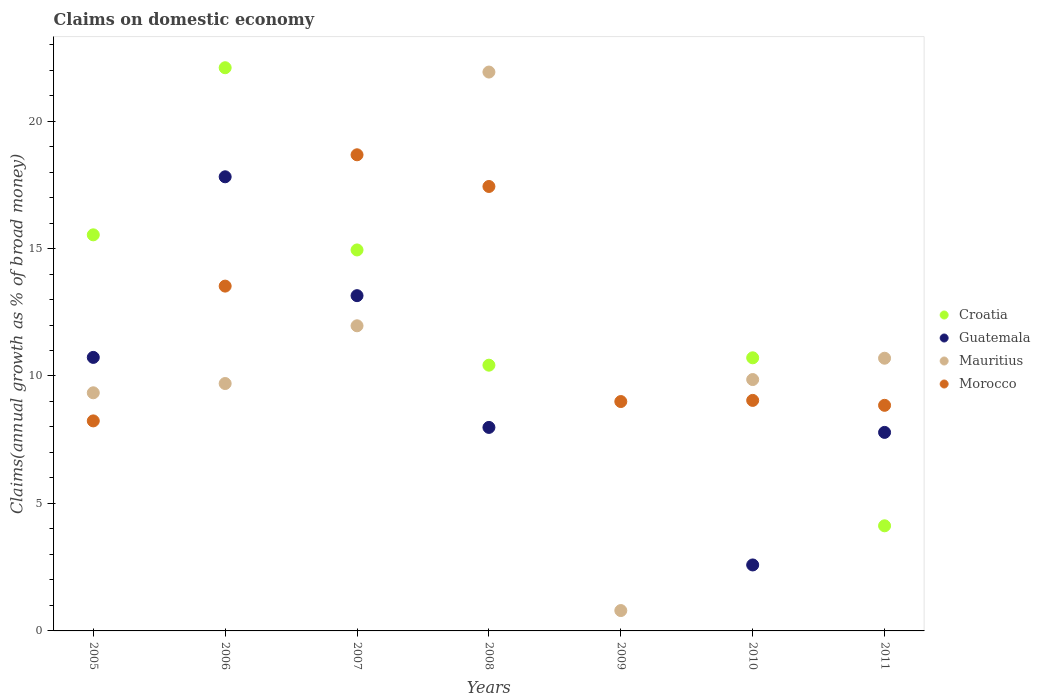Is the number of dotlines equal to the number of legend labels?
Offer a very short reply. No. What is the percentage of broad money claimed on domestic economy in Croatia in 2008?
Offer a very short reply. 10.42. Across all years, what is the maximum percentage of broad money claimed on domestic economy in Croatia?
Offer a very short reply. 22.09. Across all years, what is the minimum percentage of broad money claimed on domestic economy in Morocco?
Your answer should be compact. 8.24. In which year was the percentage of broad money claimed on domestic economy in Mauritius maximum?
Make the answer very short. 2008. What is the total percentage of broad money claimed on domestic economy in Morocco in the graph?
Your response must be concise. 84.77. What is the difference between the percentage of broad money claimed on domestic economy in Mauritius in 2008 and that in 2009?
Your answer should be very brief. 21.12. What is the difference between the percentage of broad money claimed on domestic economy in Mauritius in 2005 and the percentage of broad money claimed on domestic economy in Croatia in 2009?
Your answer should be compact. 9.34. What is the average percentage of broad money claimed on domestic economy in Mauritius per year?
Your answer should be compact. 10.61. In the year 2007, what is the difference between the percentage of broad money claimed on domestic economy in Croatia and percentage of broad money claimed on domestic economy in Mauritius?
Give a very brief answer. 2.97. What is the ratio of the percentage of broad money claimed on domestic economy in Morocco in 2010 to that in 2011?
Provide a succinct answer. 1.02. Is the percentage of broad money claimed on domestic economy in Mauritius in 2005 less than that in 2007?
Ensure brevity in your answer.  Yes. Is the difference between the percentage of broad money claimed on domestic economy in Croatia in 2005 and 2011 greater than the difference between the percentage of broad money claimed on domestic economy in Mauritius in 2005 and 2011?
Keep it short and to the point. Yes. What is the difference between the highest and the second highest percentage of broad money claimed on domestic economy in Mauritius?
Offer a terse response. 9.95. What is the difference between the highest and the lowest percentage of broad money claimed on domestic economy in Croatia?
Your answer should be very brief. 22.09. Does the percentage of broad money claimed on domestic economy in Guatemala monotonically increase over the years?
Your answer should be very brief. No. Is the percentage of broad money claimed on domestic economy in Morocco strictly greater than the percentage of broad money claimed on domestic economy in Mauritius over the years?
Make the answer very short. No. How many dotlines are there?
Offer a very short reply. 4. Are the values on the major ticks of Y-axis written in scientific E-notation?
Offer a very short reply. No. How are the legend labels stacked?
Ensure brevity in your answer.  Vertical. What is the title of the graph?
Offer a very short reply. Claims on domestic economy. What is the label or title of the Y-axis?
Keep it short and to the point. Claims(annual growth as % of broad money). What is the Claims(annual growth as % of broad money) in Croatia in 2005?
Make the answer very short. 15.54. What is the Claims(annual growth as % of broad money) in Guatemala in 2005?
Ensure brevity in your answer.  10.73. What is the Claims(annual growth as % of broad money) of Mauritius in 2005?
Ensure brevity in your answer.  9.34. What is the Claims(annual growth as % of broad money) in Morocco in 2005?
Provide a succinct answer. 8.24. What is the Claims(annual growth as % of broad money) of Croatia in 2006?
Your answer should be very brief. 22.09. What is the Claims(annual growth as % of broad money) in Guatemala in 2006?
Give a very brief answer. 17.81. What is the Claims(annual growth as % of broad money) in Mauritius in 2006?
Your answer should be compact. 9.7. What is the Claims(annual growth as % of broad money) of Morocco in 2006?
Provide a succinct answer. 13.53. What is the Claims(annual growth as % of broad money) of Croatia in 2007?
Your answer should be compact. 14.94. What is the Claims(annual growth as % of broad money) in Guatemala in 2007?
Offer a terse response. 13.15. What is the Claims(annual growth as % of broad money) in Mauritius in 2007?
Give a very brief answer. 11.97. What is the Claims(annual growth as % of broad money) of Morocco in 2007?
Give a very brief answer. 18.68. What is the Claims(annual growth as % of broad money) of Croatia in 2008?
Provide a short and direct response. 10.42. What is the Claims(annual growth as % of broad money) in Guatemala in 2008?
Give a very brief answer. 7.98. What is the Claims(annual growth as % of broad money) of Mauritius in 2008?
Keep it short and to the point. 21.92. What is the Claims(annual growth as % of broad money) in Morocco in 2008?
Offer a terse response. 17.43. What is the Claims(annual growth as % of broad money) in Mauritius in 2009?
Give a very brief answer. 0.8. What is the Claims(annual growth as % of broad money) of Morocco in 2009?
Your answer should be compact. 9. What is the Claims(annual growth as % of broad money) in Croatia in 2010?
Your response must be concise. 10.71. What is the Claims(annual growth as % of broad money) in Guatemala in 2010?
Your answer should be very brief. 2.59. What is the Claims(annual growth as % of broad money) of Mauritius in 2010?
Give a very brief answer. 9.86. What is the Claims(annual growth as % of broad money) of Morocco in 2010?
Give a very brief answer. 9.04. What is the Claims(annual growth as % of broad money) of Croatia in 2011?
Make the answer very short. 4.12. What is the Claims(annual growth as % of broad money) of Guatemala in 2011?
Provide a succinct answer. 7.79. What is the Claims(annual growth as % of broad money) of Mauritius in 2011?
Offer a very short reply. 10.7. What is the Claims(annual growth as % of broad money) of Morocco in 2011?
Provide a succinct answer. 8.85. Across all years, what is the maximum Claims(annual growth as % of broad money) of Croatia?
Provide a succinct answer. 22.09. Across all years, what is the maximum Claims(annual growth as % of broad money) of Guatemala?
Make the answer very short. 17.81. Across all years, what is the maximum Claims(annual growth as % of broad money) of Mauritius?
Give a very brief answer. 21.92. Across all years, what is the maximum Claims(annual growth as % of broad money) in Morocco?
Ensure brevity in your answer.  18.68. Across all years, what is the minimum Claims(annual growth as % of broad money) of Croatia?
Offer a very short reply. 0. Across all years, what is the minimum Claims(annual growth as % of broad money) of Mauritius?
Your answer should be very brief. 0.8. Across all years, what is the minimum Claims(annual growth as % of broad money) of Morocco?
Your response must be concise. 8.24. What is the total Claims(annual growth as % of broad money) of Croatia in the graph?
Give a very brief answer. 77.84. What is the total Claims(annual growth as % of broad money) in Guatemala in the graph?
Keep it short and to the point. 60.05. What is the total Claims(annual growth as % of broad money) of Mauritius in the graph?
Your answer should be compact. 74.29. What is the total Claims(annual growth as % of broad money) of Morocco in the graph?
Offer a terse response. 84.77. What is the difference between the Claims(annual growth as % of broad money) in Croatia in 2005 and that in 2006?
Your response must be concise. -6.55. What is the difference between the Claims(annual growth as % of broad money) in Guatemala in 2005 and that in 2006?
Make the answer very short. -7.08. What is the difference between the Claims(annual growth as % of broad money) in Mauritius in 2005 and that in 2006?
Keep it short and to the point. -0.36. What is the difference between the Claims(annual growth as % of broad money) in Morocco in 2005 and that in 2006?
Provide a succinct answer. -5.29. What is the difference between the Claims(annual growth as % of broad money) in Croatia in 2005 and that in 2007?
Keep it short and to the point. 0.59. What is the difference between the Claims(annual growth as % of broad money) in Guatemala in 2005 and that in 2007?
Offer a terse response. -2.42. What is the difference between the Claims(annual growth as % of broad money) in Mauritius in 2005 and that in 2007?
Keep it short and to the point. -2.63. What is the difference between the Claims(annual growth as % of broad money) of Morocco in 2005 and that in 2007?
Your answer should be very brief. -10.44. What is the difference between the Claims(annual growth as % of broad money) of Croatia in 2005 and that in 2008?
Your response must be concise. 5.11. What is the difference between the Claims(annual growth as % of broad money) in Guatemala in 2005 and that in 2008?
Offer a very short reply. 2.75. What is the difference between the Claims(annual growth as % of broad money) in Mauritius in 2005 and that in 2008?
Offer a very short reply. -12.58. What is the difference between the Claims(annual growth as % of broad money) of Morocco in 2005 and that in 2008?
Provide a short and direct response. -9.2. What is the difference between the Claims(annual growth as % of broad money) in Mauritius in 2005 and that in 2009?
Your response must be concise. 8.54. What is the difference between the Claims(annual growth as % of broad money) in Morocco in 2005 and that in 2009?
Provide a short and direct response. -0.76. What is the difference between the Claims(annual growth as % of broad money) of Croatia in 2005 and that in 2010?
Ensure brevity in your answer.  4.82. What is the difference between the Claims(annual growth as % of broad money) in Guatemala in 2005 and that in 2010?
Your response must be concise. 8.14. What is the difference between the Claims(annual growth as % of broad money) of Mauritius in 2005 and that in 2010?
Ensure brevity in your answer.  -0.52. What is the difference between the Claims(annual growth as % of broad money) in Morocco in 2005 and that in 2010?
Offer a terse response. -0.8. What is the difference between the Claims(annual growth as % of broad money) of Croatia in 2005 and that in 2011?
Your response must be concise. 11.41. What is the difference between the Claims(annual growth as % of broad money) in Guatemala in 2005 and that in 2011?
Offer a very short reply. 2.94. What is the difference between the Claims(annual growth as % of broad money) in Mauritius in 2005 and that in 2011?
Offer a very short reply. -1.36. What is the difference between the Claims(annual growth as % of broad money) in Morocco in 2005 and that in 2011?
Your response must be concise. -0.61. What is the difference between the Claims(annual growth as % of broad money) in Croatia in 2006 and that in 2007?
Your answer should be very brief. 7.15. What is the difference between the Claims(annual growth as % of broad money) of Guatemala in 2006 and that in 2007?
Make the answer very short. 4.66. What is the difference between the Claims(annual growth as % of broad money) in Mauritius in 2006 and that in 2007?
Provide a short and direct response. -2.27. What is the difference between the Claims(annual growth as % of broad money) of Morocco in 2006 and that in 2007?
Offer a very short reply. -5.15. What is the difference between the Claims(annual growth as % of broad money) of Croatia in 2006 and that in 2008?
Your answer should be very brief. 11.67. What is the difference between the Claims(annual growth as % of broad money) of Guatemala in 2006 and that in 2008?
Provide a succinct answer. 9.83. What is the difference between the Claims(annual growth as % of broad money) of Mauritius in 2006 and that in 2008?
Your response must be concise. -12.22. What is the difference between the Claims(annual growth as % of broad money) of Morocco in 2006 and that in 2008?
Your response must be concise. -3.91. What is the difference between the Claims(annual growth as % of broad money) of Mauritius in 2006 and that in 2009?
Give a very brief answer. 8.91. What is the difference between the Claims(annual growth as % of broad money) in Morocco in 2006 and that in 2009?
Your response must be concise. 4.53. What is the difference between the Claims(annual growth as % of broad money) in Croatia in 2006 and that in 2010?
Make the answer very short. 11.38. What is the difference between the Claims(annual growth as % of broad money) of Guatemala in 2006 and that in 2010?
Your response must be concise. 15.23. What is the difference between the Claims(annual growth as % of broad money) of Mauritius in 2006 and that in 2010?
Ensure brevity in your answer.  -0.16. What is the difference between the Claims(annual growth as % of broad money) of Morocco in 2006 and that in 2010?
Keep it short and to the point. 4.48. What is the difference between the Claims(annual growth as % of broad money) in Croatia in 2006 and that in 2011?
Your response must be concise. 17.97. What is the difference between the Claims(annual growth as % of broad money) of Guatemala in 2006 and that in 2011?
Ensure brevity in your answer.  10.03. What is the difference between the Claims(annual growth as % of broad money) of Mauritius in 2006 and that in 2011?
Ensure brevity in your answer.  -0.99. What is the difference between the Claims(annual growth as % of broad money) of Morocco in 2006 and that in 2011?
Offer a very short reply. 4.68. What is the difference between the Claims(annual growth as % of broad money) in Croatia in 2007 and that in 2008?
Make the answer very short. 4.52. What is the difference between the Claims(annual growth as % of broad money) of Guatemala in 2007 and that in 2008?
Ensure brevity in your answer.  5.17. What is the difference between the Claims(annual growth as % of broad money) in Mauritius in 2007 and that in 2008?
Provide a short and direct response. -9.95. What is the difference between the Claims(annual growth as % of broad money) of Morocco in 2007 and that in 2008?
Offer a terse response. 1.24. What is the difference between the Claims(annual growth as % of broad money) of Mauritius in 2007 and that in 2009?
Keep it short and to the point. 11.17. What is the difference between the Claims(annual growth as % of broad money) in Morocco in 2007 and that in 2009?
Make the answer very short. 9.68. What is the difference between the Claims(annual growth as % of broad money) of Croatia in 2007 and that in 2010?
Your answer should be very brief. 4.23. What is the difference between the Claims(annual growth as % of broad money) of Guatemala in 2007 and that in 2010?
Offer a terse response. 10.56. What is the difference between the Claims(annual growth as % of broad money) of Mauritius in 2007 and that in 2010?
Your answer should be very brief. 2.11. What is the difference between the Claims(annual growth as % of broad money) in Morocco in 2007 and that in 2010?
Offer a very short reply. 9.63. What is the difference between the Claims(annual growth as % of broad money) in Croatia in 2007 and that in 2011?
Offer a very short reply. 10.82. What is the difference between the Claims(annual growth as % of broad money) in Guatemala in 2007 and that in 2011?
Give a very brief answer. 5.36. What is the difference between the Claims(annual growth as % of broad money) of Mauritius in 2007 and that in 2011?
Your response must be concise. 1.27. What is the difference between the Claims(annual growth as % of broad money) of Morocco in 2007 and that in 2011?
Ensure brevity in your answer.  9.83. What is the difference between the Claims(annual growth as % of broad money) in Mauritius in 2008 and that in 2009?
Your response must be concise. 21.12. What is the difference between the Claims(annual growth as % of broad money) in Morocco in 2008 and that in 2009?
Ensure brevity in your answer.  8.44. What is the difference between the Claims(annual growth as % of broad money) of Croatia in 2008 and that in 2010?
Ensure brevity in your answer.  -0.29. What is the difference between the Claims(annual growth as % of broad money) of Guatemala in 2008 and that in 2010?
Your answer should be compact. 5.39. What is the difference between the Claims(annual growth as % of broad money) of Mauritius in 2008 and that in 2010?
Give a very brief answer. 12.06. What is the difference between the Claims(annual growth as % of broad money) in Morocco in 2008 and that in 2010?
Keep it short and to the point. 8.39. What is the difference between the Claims(annual growth as % of broad money) in Croatia in 2008 and that in 2011?
Make the answer very short. 6.3. What is the difference between the Claims(annual growth as % of broad money) of Guatemala in 2008 and that in 2011?
Your answer should be very brief. 0.2. What is the difference between the Claims(annual growth as % of broad money) of Mauritius in 2008 and that in 2011?
Your response must be concise. 11.23. What is the difference between the Claims(annual growth as % of broad money) in Morocco in 2008 and that in 2011?
Provide a succinct answer. 8.58. What is the difference between the Claims(annual growth as % of broad money) of Mauritius in 2009 and that in 2010?
Provide a succinct answer. -9.06. What is the difference between the Claims(annual growth as % of broad money) of Morocco in 2009 and that in 2010?
Your response must be concise. -0.04. What is the difference between the Claims(annual growth as % of broad money) of Mauritius in 2009 and that in 2011?
Provide a succinct answer. -9.9. What is the difference between the Claims(annual growth as % of broad money) of Morocco in 2009 and that in 2011?
Your answer should be very brief. 0.15. What is the difference between the Claims(annual growth as % of broad money) of Croatia in 2010 and that in 2011?
Provide a short and direct response. 6.59. What is the difference between the Claims(annual growth as % of broad money) of Guatemala in 2010 and that in 2011?
Provide a succinct answer. -5.2. What is the difference between the Claims(annual growth as % of broad money) of Mauritius in 2010 and that in 2011?
Keep it short and to the point. -0.84. What is the difference between the Claims(annual growth as % of broad money) of Morocco in 2010 and that in 2011?
Offer a terse response. 0.19. What is the difference between the Claims(annual growth as % of broad money) in Croatia in 2005 and the Claims(annual growth as % of broad money) in Guatemala in 2006?
Your answer should be very brief. -2.28. What is the difference between the Claims(annual growth as % of broad money) of Croatia in 2005 and the Claims(annual growth as % of broad money) of Mauritius in 2006?
Your answer should be very brief. 5.83. What is the difference between the Claims(annual growth as % of broad money) in Croatia in 2005 and the Claims(annual growth as % of broad money) in Morocco in 2006?
Ensure brevity in your answer.  2.01. What is the difference between the Claims(annual growth as % of broad money) in Guatemala in 2005 and the Claims(annual growth as % of broad money) in Mauritius in 2006?
Provide a short and direct response. 1.02. What is the difference between the Claims(annual growth as % of broad money) of Guatemala in 2005 and the Claims(annual growth as % of broad money) of Morocco in 2006?
Provide a short and direct response. -2.8. What is the difference between the Claims(annual growth as % of broad money) in Mauritius in 2005 and the Claims(annual growth as % of broad money) in Morocco in 2006?
Give a very brief answer. -4.18. What is the difference between the Claims(annual growth as % of broad money) of Croatia in 2005 and the Claims(annual growth as % of broad money) of Guatemala in 2007?
Give a very brief answer. 2.39. What is the difference between the Claims(annual growth as % of broad money) of Croatia in 2005 and the Claims(annual growth as % of broad money) of Mauritius in 2007?
Provide a succinct answer. 3.57. What is the difference between the Claims(annual growth as % of broad money) in Croatia in 2005 and the Claims(annual growth as % of broad money) in Morocco in 2007?
Your answer should be compact. -3.14. What is the difference between the Claims(annual growth as % of broad money) of Guatemala in 2005 and the Claims(annual growth as % of broad money) of Mauritius in 2007?
Provide a short and direct response. -1.24. What is the difference between the Claims(annual growth as % of broad money) of Guatemala in 2005 and the Claims(annual growth as % of broad money) of Morocco in 2007?
Provide a short and direct response. -7.95. What is the difference between the Claims(annual growth as % of broad money) in Mauritius in 2005 and the Claims(annual growth as % of broad money) in Morocco in 2007?
Ensure brevity in your answer.  -9.34. What is the difference between the Claims(annual growth as % of broad money) of Croatia in 2005 and the Claims(annual growth as % of broad money) of Guatemala in 2008?
Provide a succinct answer. 7.55. What is the difference between the Claims(annual growth as % of broad money) in Croatia in 2005 and the Claims(annual growth as % of broad money) in Mauritius in 2008?
Your response must be concise. -6.39. What is the difference between the Claims(annual growth as % of broad money) of Croatia in 2005 and the Claims(annual growth as % of broad money) of Morocco in 2008?
Offer a terse response. -1.9. What is the difference between the Claims(annual growth as % of broad money) of Guatemala in 2005 and the Claims(annual growth as % of broad money) of Mauritius in 2008?
Make the answer very short. -11.19. What is the difference between the Claims(annual growth as % of broad money) of Guatemala in 2005 and the Claims(annual growth as % of broad money) of Morocco in 2008?
Provide a short and direct response. -6.7. What is the difference between the Claims(annual growth as % of broad money) in Mauritius in 2005 and the Claims(annual growth as % of broad money) in Morocco in 2008?
Provide a succinct answer. -8.09. What is the difference between the Claims(annual growth as % of broad money) of Croatia in 2005 and the Claims(annual growth as % of broad money) of Mauritius in 2009?
Your answer should be very brief. 14.74. What is the difference between the Claims(annual growth as % of broad money) in Croatia in 2005 and the Claims(annual growth as % of broad money) in Morocco in 2009?
Keep it short and to the point. 6.54. What is the difference between the Claims(annual growth as % of broad money) in Guatemala in 2005 and the Claims(annual growth as % of broad money) in Mauritius in 2009?
Offer a very short reply. 9.93. What is the difference between the Claims(annual growth as % of broad money) of Guatemala in 2005 and the Claims(annual growth as % of broad money) of Morocco in 2009?
Make the answer very short. 1.73. What is the difference between the Claims(annual growth as % of broad money) of Mauritius in 2005 and the Claims(annual growth as % of broad money) of Morocco in 2009?
Provide a short and direct response. 0.34. What is the difference between the Claims(annual growth as % of broad money) in Croatia in 2005 and the Claims(annual growth as % of broad money) in Guatemala in 2010?
Give a very brief answer. 12.95. What is the difference between the Claims(annual growth as % of broad money) of Croatia in 2005 and the Claims(annual growth as % of broad money) of Mauritius in 2010?
Your response must be concise. 5.68. What is the difference between the Claims(annual growth as % of broad money) of Croatia in 2005 and the Claims(annual growth as % of broad money) of Morocco in 2010?
Offer a terse response. 6.49. What is the difference between the Claims(annual growth as % of broad money) of Guatemala in 2005 and the Claims(annual growth as % of broad money) of Mauritius in 2010?
Provide a succinct answer. 0.87. What is the difference between the Claims(annual growth as % of broad money) in Guatemala in 2005 and the Claims(annual growth as % of broad money) in Morocco in 2010?
Keep it short and to the point. 1.69. What is the difference between the Claims(annual growth as % of broad money) in Mauritius in 2005 and the Claims(annual growth as % of broad money) in Morocco in 2010?
Give a very brief answer. 0.3. What is the difference between the Claims(annual growth as % of broad money) of Croatia in 2005 and the Claims(annual growth as % of broad money) of Guatemala in 2011?
Your answer should be compact. 7.75. What is the difference between the Claims(annual growth as % of broad money) in Croatia in 2005 and the Claims(annual growth as % of broad money) in Mauritius in 2011?
Provide a succinct answer. 4.84. What is the difference between the Claims(annual growth as % of broad money) of Croatia in 2005 and the Claims(annual growth as % of broad money) of Morocco in 2011?
Your answer should be compact. 6.69. What is the difference between the Claims(annual growth as % of broad money) in Guatemala in 2005 and the Claims(annual growth as % of broad money) in Mauritius in 2011?
Offer a very short reply. 0.03. What is the difference between the Claims(annual growth as % of broad money) of Guatemala in 2005 and the Claims(annual growth as % of broad money) of Morocco in 2011?
Offer a very short reply. 1.88. What is the difference between the Claims(annual growth as % of broad money) of Mauritius in 2005 and the Claims(annual growth as % of broad money) of Morocco in 2011?
Provide a short and direct response. 0.49. What is the difference between the Claims(annual growth as % of broad money) of Croatia in 2006 and the Claims(annual growth as % of broad money) of Guatemala in 2007?
Offer a very short reply. 8.94. What is the difference between the Claims(annual growth as % of broad money) in Croatia in 2006 and the Claims(annual growth as % of broad money) in Mauritius in 2007?
Ensure brevity in your answer.  10.12. What is the difference between the Claims(annual growth as % of broad money) of Croatia in 2006 and the Claims(annual growth as % of broad money) of Morocco in 2007?
Ensure brevity in your answer.  3.42. What is the difference between the Claims(annual growth as % of broad money) in Guatemala in 2006 and the Claims(annual growth as % of broad money) in Mauritius in 2007?
Keep it short and to the point. 5.84. What is the difference between the Claims(annual growth as % of broad money) in Guatemala in 2006 and the Claims(annual growth as % of broad money) in Morocco in 2007?
Keep it short and to the point. -0.86. What is the difference between the Claims(annual growth as % of broad money) in Mauritius in 2006 and the Claims(annual growth as % of broad money) in Morocco in 2007?
Provide a succinct answer. -8.97. What is the difference between the Claims(annual growth as % of broad money) of Croatia in 2006 and the Claims(annual growth as % of broad money) of Guatemala in 2008?
Make the answer very short. 14.11. What is the difference between the Claims(annual growth as % of broad money) of Croatia in 2006 and the Claims(annual growth as % of broad money) of Mauritius in 2008?
Provide a short and direct response. 0.17. What is the difference between the Claims(annual growth as % of broad money) in Croatia in 2006 and the Claims(annual growth as % of broad money) in Morocco in 2008?
Provide a succinct answer. 4.66. What is the difference between the Claims(annual growth as % of broad money) in Guatemala in 2006 and the Claims(annual growth as % of broad money) in Mauritius in 2008?
Offer a very short reply. -4.11. What is the difference between the Claims(annual growth as % of broad money) in Guatemala in 2006 and the Claims(annual growth as % of broad money) in Morocco in 2008?
Your response must be concise. 0.38. What is the difference between the Claims(annual growth as % of broad money) in Mauritius in 2006 and the Claims(annual growth as % of broad money) in Morocco in 2008?
Make the answer very short. -7.73. What is the difference between the Claims(annual growth as % of broad money) of Croatia in 2006 and the Claims(annual growth as % of broad money) of Mauritius in 2009?
Your answer should be very brief. 21.29. What is the difference between the Claims(annual growth as % of broad money) of Croatia in 2006 and the Claims(annual growth as % of broad money) of Morocco in 2009?
Provide a succinct answer. 13.09. What is the difference between the Claims(annual growth as % of broad money) of Guatemala in 2006 and the Claims(annual growth as % of broad money) of Mauritius in 2009?
Give a very brief answer. 17.02. What is the difference between the Claims(annual growth as % of broad money) in Guatemala in 2006 and the Claims(annual growth as % of broad money) in Morocco in 2009?
Give a very brief answer. 8.82. What is the difference between the Claims(annual growth as % of broad money) in Mauritius in 2006 and the Claims(annual growth as % of broad money) in Morocco in 2009?
Provide a succinct answer. 0.71. What is the difference between the Claims(annual growth as % of broad money) in Croatia in 2006 and the Claims(annual growth as % of broad money) in Guatemala in 2010?
Offer a very short reply. 19.5. What is the difference between the Claims(annual growth as % of broad money) in Croatia in 2006 and the Claims(annual growth as % of broad money) in Mauritius in 2010?
Provide a succinct answer. 12.23. What is the difference between the Claims(annual growth as % of broad money) of Croatia in 2006 and the Claims(annual growth as % of broad money) of Morocco in 2010?
Ensure brevity in your answer.  13.05. What is the difference between the Claims(annual growth as % of broad money) of Guatemala in 2006 and the Claims(annual growth as % of broad money) of Mauritius in 2010?
Provide a short and direct response. 7.95. What is the difference between the Claims(annual growth as % of broad money) of Guatemala in 2006 and the Claims(annual growth as % of broad money) of Morocco in 2010?
Your response must be concise. 8.77. What is the difference between the Claims(annual growth as % of broad money) in Mauritius in 2006 and the Claims(annual growth as % of broad money) in Morocco in 2010?
Give a very brief answer. 0.66. What is the difference between the Claims(annual growth as % of broad money) of Croatia in 2006 and the Claims(annual growth as % of broad money) of Guatemala in 2011?
Offer a terse response. 14.3. What is the difference between the Claims(annual growth as % of broad money) in Croatia in 2006 and the Claims(annual growth as % of broad money) in Mauritius in 2011?
Provide a succinct answer. 11.39. What is the difference between the Claims(annual growth as % of broad money) in Croatia in 2006 and the Claims(annual growth as % of broad money) in Morocco in 2011?
Give a very brief answer. 13.24. What is the difference between the Claims(annual growth as % of broad money) in Guatemala in 2006 and the Claims(annual growth as % of broad money) in Mauritius in 2011?
Offer a terse response. 7.12. What is the difference between the Claims(annual growth as % of broad money) of Guatemala in 2006 and the Claims(annual growth as % of broad money) of Morocco in 2011?
Ensure brevity in your answer.  8.96. What is the difference between the Claims(annual growth as % of broad money) in Mauritius in 2006 and the Claims(annual growth as % of broad money) in Morocco in 2011?
Provide a short and direct response. 0.85. What is the difference between the Claims(annual growth as % of broad money) of Croatia in 2007 and the Claims(annual growth as % of broad money) of Guatemala in 2008?
Offer a very short reply. 6.96. What is the difference between the Claims(annual growth as % of broad money) of Croatia in 2007 and the Claims(annual growth as % of broad money) of Mauritius in 2008?
Provide a short and direct response. -6.98. What is the difference between the Claims(annual growth as % of broad money) of Croatia in 2007 and the Claims(annual growth as % of broad money) of Morocco in 2008?
Provide a succinct answer. -2.49. What is the difference between the Claims(annual growth as % of broad money) in Guatemala in 2007 and the Claims(annual growth as % of broad money) in Mauritius in 2008?
Give a very brief answer. -8.77. What is the difference between the Claims(annual growth as % of broad money) in Guatemala in 2007 and the Claims(annual growth as % of broad money) in Morocco in 2008?
Provide a succinct answer. -4.28. What is the difference between the Claims(annual growth as % of broad money) of Mauritius in 2007 and the Claims(annual growth as % of broad money) of Morocco in 2008?
Provide a short and direct response. -5.46. What is the difference between the Claims(annual growth as % of broad money) in Croatia in 2007 and the Claims(annual growth as % of broad money) in Mauritius in 2009?
Give a very brief answer. 14.15. What is the difference between the Claims(annual growth as % of broad money) of Croatia in 2007 and the Claims(annual growth as % of broad money) of Morocco in 2009?
Give a very brief answer. 5.95. What is the difference between the Claims(annual growth as % of broad money) in Guatemala in 2007 and the Claims(annual growth as % of broad money) in Mauritius in 2009?
Offer a terse response. 12.35. What is the difference between the Claims(annual growth as % of broad money) of Guatemala in 2007 and the Claims(annual growth as % of broad money) of Morocco in 2009?
Your answer should be very brief. 4.15. What is the difference between the Claims(annual growth as % of broad money) in Mauritius in 2007 and the Claims(annual growth as % of broad money) in Morocco in 2009?
Make the answer very short. 2.97. What is the difference between the Claims(annual growth as % of broad money) of Croatia in 2007 and the Claims(annual growth as % of broad money) of Guatemala in 2010?
Provide a succinct answer. 12.36. What is the difference between the Claims(annual growth as % of broad money) in Croatia in 2007 and the Claims(annual growth as % of broad money) in Mauritius in 2010?
Make the answer very short. 5.08. What is the difference between the Claims(annual growth as % of broad money) in Croatia in 2007 and the Claims(annual growth as % of broad money) in Morocco in 2010?
Provide a short and direct response. 5.9. What is the difference between the Claims(annual growth as % of broad money) in Guatemala in 2007 and the Claims(annual growth as % of broad money) in Mauritius in 2010?
Provide a short and direct response. 3.29. What is the difference between the Claims(annual growth as % of broad money) in Guatemala in 2007 and the Claims(annual growth as % of broad money) in Morocco in 2010?
Provide a succinct answer. 4.11. What is the difference between the Claims(annual growth as % of broad money) in Mauritius in 2007 and the Claims(annual growth as % of broad money) in Morocco in 2010?
Ensure brevity in your answer.  2.93. What is the difference between the Claims(annual growth as % of broad money) of Croatia in 2007 and the Claims(annual growth as % of broad money) of Guatemala in 2011?
Your answer should be compact. 7.16. What is the difference between the Claims(annual growth as % of broad money) of Croatia in 2007 and the Claims(annual growth as % of broad money) of Mauritius in 2011?
Your response must be concise. 4.25. What is the difference between the Claims(annual growth as % of broad money) of Croatia in 2007 and the Claims(annual growth as % of broad money) of Morocco in 2011?
Offer a very short reply. 6.09. What is the difference between the Claims(annual growth as % of broad money) in Guatemala in 2007 and the Claims(annual growth as % of broad money) in Mauritius in 2011?
Provide a short and direct response. 2.45. What is the difference between the Claims(annual growth as % of broad money) in Guatemala in 2007 and the Claims(annual growth as % of broad money) in Morocco in 2011?
Your answer should be very brief. 4.3. What is the difference between the Claims(annual growth as % of broad money) in Mauritius in 2007 and the Claims(annual growth as % of broad money) in Morocco in 2011?
Provide a short and direct response. 3.12. What is the difference between the Claims(annual growth as % of broad money) in Croatia in 2008 and the Claims(annual growth as % of broad money) in Mauritius in 2009?
Your answer should be very brief. 9.63. What is the difference between the Claims(annual growth as % of broad money) of Croatia in 2008 and the Claims(annual growth as % of broad money) of Morocco in 2009?
Provide a succinct answer. 1.43. What is the difference between the Claims(annual growth as % of broad money) in Guatemala in 2008 and the Claims(annual growth as % of broad money) in Mauritius in 2009?
Offer a terse response. 7.18. What is the difference between the Claims(annual growth as % of broad money) of Guatemala in 2008 and the Claims(annual growth as % of broad money) of Morocco in 2009?
Ensure brevity in your answer.  -1.01. What is the difference between the Claims(annual growth as % of broad money) in Mauritius in 2008 and the Claims(annual growth as % of broad money) in Morocco in 2009?
Offer a very short reply. 12.93. What is the difference between the Claims(annual growth as % of broad money) in Croatia in 2008 and the Claims(annual growth as % of broad money) in Guatemala in 2010?
Ensure brevity in your answer.  7.84. What is the difference between the Claims(annual growth as % of broad money) in Croatia in 2008 and the Claims(annual growth as % of broad money) in Mauritius in 2010?
Offer a terse response. 0.56. What is the difference between the Claims(annual growth as % of broad money) in Croatia in 2008 and the Claims(annual growth as % of broad money) in Morocco in 2010?
Provide a succinct answer. 1.38. What is the difference between the Claims(annual growth as % of broad money) in Guatemala in 2008 and the Claims(annual growth as % of broad money) in Mauritius in 2010?
Your response must be concise. -1.88. What is the difference between the Claims(annual growth as % of broad money) of Guatemala in 2008 and the Claims(annual growth as % of broad money) of Morocco in 2010?
Keep it short and to the point. -1.06. What is the difference between the Claims(annual growth as % of broad money) of Mauritius in 2008 and the Claims(annual growth as % of broad money) of Morocco in 2010?
Your answer should be compact. 12.88. What is the difference between the Claims(annual growth as % of broad money) in Croatia in 2008 and the Claims(annual growth as % of broad money) in Guatemala in 2011?
Your response must be concise. 2.64. What is the difference between the Claims(annual growth as % of broad money) of Croatia in 2008 and the Claims(annual growth as % of broad money) of Mauritius in 2011?
Keep it short and to the point. -0.27. What is the difference between the Claims(annual growth as % of broad money) in Croatia in 2008 and the Claims(annual growth as % of broad money) in Morocco in 2011?
Offer a terse response. 1.57. What is the difference between the Claims(annual growth as % of broad money) of Guatemala in 2008 and the Claims(annual growth as % of broad money) of Mauritius in 2011?
Provide a short and direct response. -2.71. What is the difference between the Claims(annual growth as % of broad money) of Guatemala in 2008 and the Claims(annual growth as % of broad money) of Morocco in 2011?
Offer a very short reply. -0.87. What is the difference between the Claims(annual growth as % of broad money) in Mauritius in 2008 and the Claims(annual growth as % of broad money) in Morocco in 2011?
Make the answer very short. 13.07. What is the difference between the Claims(annual growth as % of broad money) of Mauritius in 2009 and the Claims(annual growth as % of broad money) of Morocco in 2010?
Your response must be concise. -8.24. What is the difference between the Claims(annual growth as % of broad money) of Mauritius in 2009 and the Claims(annual growth as % of broad money) of Morocco in 2011?
Keep it short and to the point. -8.05. What is the difference between the Claims(annual growth as % of broad money) in Croatia in 2010 and the Claims(annual growth as % of broad money) in Guatemala in 2011?
Offer a very short reply. 2.93. What is the difference between the Claims(annual growth as % of broad money) in Croatia in 2010 and the Claims(annual growth as % of broad money) in Mauritius in 2011?
Your answer should be compact. 0.02. What is the difference between the Claims(annual growth as % of broad money) in Croatia in 2010 and the Claims(annual growth as % of broad money) in Morocco in 2011?
Ensure brevity in your answer.  1.86. What is the difference between the Claims(annual growth as % of broad money) of Guatemala in 2010 and the Claims(annual growth as % of broad money) of Mauritius in 2011?
Your answer should be very brief. -8.11. What is the difference between the Claims(annual growth as % of broad money) in Guatemala in 2010 and the Claims(annual growth as % of broad money) in Morocco in 2011?
Your answer should be compact. -6.26. What is the difference between the Claims(annual growth as % of broad money) in Mauritius in 2010 and the Claims(annual growth as % of broad money) in Morocco in 2011?
Offer a very short reply. 1.01. What is the average Claims(annual growth as % of broad money) in Croatia per year?
Your answer should be compact. 11.12. What is the average Claims(annual growth as % of broad money) in Guatemala per year?
Your answer should be very brief. 8.58. What is the average Claims(annual growth as % of broad money) of Mauritius per year?
Offer a terse response. 10.61. What is the average Claims(annual growth as % of broad money) of Morocco per year?
Ensure brevity in your answer.  12.11. In the year 2005, what is the difference between the Claims(annual growth as % of broad money) in Croatia and Claims(annual growth as % of broad money) in Guatemala?
Make the answer very short. 4.81. In the year 2005, what is the difference between the Claims(annual growth as % of broad money) of Croatia and Claims(annual growth as % of broad money) of Mauritius?
Offer a terse response. 6.2. In the year 2005, what is the difference between the Claims(annual growth as % of broad money) in Croatia and Claims(annual growth as % of broad money) in Morocco?
Keep it short and to the point. 7.3. In the year 2005, what is the difference between the Claims(annual growth as % of broad money) in Guatemala and Claims(annual growth as % of broad money) in Mauritius?
Make the answer very short. 1.39. In the year 2005, what is the difference between the Claims(annual growth as % of broad money) in Guatemala and Claims(annual growth as % of broad money) in Morocco?
Give a very brief answer. 2.49. In the year 2005, what is the difference between the Claims(annual growth as % of broad money) in Mauritius and Claims(annual growth as % of broad money) in Morocco?
Your response must be concise. 1.1. In the year 2006, what is the difference between the Claims(annual growth as % of broad money) of Croatia and Claims(annual growth as % of broad money) of Guatemala?
Make the answer very short. 4.28. In the year 2006, what is the difference between the Claims(annual growth as % of broad money) in Croatia and Claims(annual growth as % of broad money) in Mauritius?
Your response must be concise. 12.39. In the year 2006, what is the difference between the Claims(annual growth as % of broad money) in Croatia and Claims(annual growth as % of broad money) in Morocco?
Make the answer very short. 8.57. In the year 2006, what is the difference between the Claims(annual growth as % of broad money) in Guatemala and Claims(annual growth as % of broad money) in Mauritius?
Your answer should be very brief. 8.11. In the year 2006, what is the difference between the Claims(annual growth as % of broad money) in Guatemala and Claims(annual growth as % of broad money) in Morocco?
Offer a very short reply. 4.29. In the year 2006, what is the difference between the Claims(annual growth as % of broad money) of Mauritius and Claims(annual growth as % of broad money) of Morocco?
Provide a short and direct response. -3.82. In the year 2007, what is the difference between the Claims(annual growth as % of broad money) in Croatia and Claims(annual growth as % of broad money) in Guatemala?
Make the answer very short. 1.79. In the year 2007, what is the difference between the Claims(annual growth as % of broad money) of Croatia and Claims(annual growth as % of broad money) of Mauritius?
Offer a very short reply. 2.97. In the year 2007, what is the difference between the Claims(annual growth as % of broad money) of Croatia and Claims(annual growth as % of broad money) of Morocco?
Make the answer very short. -3.73. In the year 2007, what is the difference between the Claims(annual growth as % of broad money) of Guatemala and Claims(annual growth as % of broad money) of Mauritius?
Give a very brief answer. 1.18. In the year 2007, what is the difference between the Claims(annual growth as % of broad money) of Guatemala and Claims(annual growth as % of broad money) of Morocco?
Your answer should be compact. -5.53. In the year 2007, what is the difference between the Claims(annual growth as % of broad money) in Mauritius and Claims(annual growth as % of broad money) in Morocco?
Provide a succinct answer. -6.71. In the year 2008, what is the difference between the Claims(annual growth as % of broad money) in Croatia and Claims(annual growth as % of broad money) in Guatemala?
Offer a very short reply. 2.44. In the year 2008, what is the difference between the Claims(annual growth as % of broad money) of Croatia and Claims(annual growth as % of broad money) of Mauritius?
Your answer should be compact. -11.5. In the year 2008, what is the difference between the Claims(annual growth as % of broad money) of Croatia and Claims(annual growth as % of broad money) of Morocco?
Your response must be concise. -7.01. In the year 2008, what is the difference between the Claims(annual growth as % of broad money) in Guatemala and Claims(annual growth as % of broad money) in Mauritius?
Your response must be concise. -13.94. In the year 2008, what is the difference between the Claims(annual growth as % of broad money) in Guatemala and Claims(annual growth as % of broad money) in Morocco?
Provide a short and direct response. -9.45. In the year 2008, what is the difference between the Claims(annual growth as % of broad money) in Mauritius and Claims(annual growth as % of broad money) in Morocco?
Your answer should be compact. 4.49. In the year 2009, what is the difference between the Claims(annual growth as % of broad money) of Mauritius and Claims(annual growth as % of broad money) of Morocco?
Make the answer very short. -8.2. In the year 2010, what is the difference between the Claims(annual growth as % of broad money) in Croatia and Claims(annual growth as % of broad money) in Guatemala?
Give a very brief answer. 8.13. In the year 2010, what is the difference between the Claims(annual growth as % of broad money) in Croatia and Claims(annual growth as % of broad money) in Mauritius?
Keep it short and to the point. 0.85. In the year 2010, what is the difference between the Claims(annual growth as % of broad money) of Croatia and Claims(annual growth as % of broad money) of Morocco?
Make the answer very short. 1.67. In the year 2010, what is the difference between the Claims(annual growth as % of broad money) of Guatemala and Claims(annual growth as % of broad money) of Mauritius?
Your response must be concise. -7.27. In the year 2010, what is the difference between the Claims(annual growth as % of broad money) of Guatemala and Claims(annual growth as % of broad money) of Morocco?
Ensure brevity in your answer.  -6.45. In the year 2010, what is the difference between the Claims(annual growth as % of broad money) of Mauritius and Claims(annual growth as % of broad money) of Morocco?
Ensure brevity in your answer.  0.82. In the year 2011, what is the difference between the Claims(annual growth as % of broad money) of Croatia and Claims(annual growth as % of broad money) of Guatemala?
Give a very brief answer. -3.66. In the year 2011, what is the difference between the Claims(annual growth as % of broad money) of Croatia and Claims(annual growth as % of broad money) of Mauritius?
Your answer should be very brief. -6.57. In the year 2011, what is the difference between the Claims(annual growth as % of broad money) of Croatia and Claims(annual growth as % of broad money) of Morocco?
Your response must be concise. -4.73. In the year 2011, what is the difference between the Claims(annual growth as % of broad money) of Guatemala and Claims(annual growth as % of broad money) of Mauritius?
Provide a short and direct response. -2.91. In the year 2011, what is the difference between the Claims(annual growth as % of broad money) in Guatemala and Claims(annual growth as % of broad money) in Morocco?
Your answer should be very brief. -1.06. In the year 2011, what is the difference between the Claims(annual growth as % of broad money) in Mauritius and Claims(annual growth as % of broad money) in Morocco?
Offer a very short reply. 1.85. What is the ratio of the Claims(annual growth as % of broad money) in Croatia in 2005 to that in 2006?
Offer a very short reply. 0.7. What is the ratio of the Claims(annual growth as % of broad money) in Guatemala in 2005 to that in 2006?
Make the answer very short. 0.6. What is the ratio of the Claims(annual growth as % of broad money) in Mauritius in 2005 to that in 2006?
Your answer should be very brief. 0.96. What is the ratio of the Claims(annual growth as % of broad money) of Morocco in 2005 to that in 2006?
Offer a very short reply. 0.61. What is the ratio of the Claims(annual growth as % of broad money) of Croatia in 2005 to that in 2007?
Provide a succinct answer. 1.04. What is the ratio of the Claims(annual growth as % of broad money) in Guatemala in 2005 to that in 2007?
Keep it short and to the point. 0.82. What is the ratio of the Claims(annual growth as % of broad money) in Mauritius in 2005 to that in 2007?
Offer a terse response. 0.78. What is the ratio of the Claims(annual growth as % of broad money) in Morocco in 2005 to that in 2007?
Your answer should be compact. 0.44. What is the ratio of the Claims(annual growth as % of broad money) of Croatia in 2005 to that in 2008?
Your answer should be compact. 1.49. What is the ratio of the Claims(annual growth as % of broad money) in Guatemala in 2005 to that in 2008?
Provide a short and direct response. 1.34. What is the ratio of the Claims(annual growth as % of broad money) in Mauritius in 2005 to that in 2008?
Keep it short and to the point. 0.43. What is the ratio of the Claims(annual growth as % of broad money) of Morocco in 2005 to that in 2008?
Your answer should be very brief. 0.47. What is the ratio of the Claims(annual growth as % of broad money) of Mauritius in 2005 to that in 2009?
Your answer should be compact. 11.7. What is the ratio of the Claims(annual growth as % of broad money) of Morocco in 2005 to that in 2009?
Make the answer very short. 0.92. What is the ratio of the Claims(annual growth as % of broad money) in Croatia in 2005 to that in 2010?
Keep it short and to the point. 1.45. What is the ratio of the Claims(annual growth as % of broad money) of Guatemala in 2005 to that in 2010?
Offer a terse response. 4.15. What is the ratio of the Claims(annual growth as % of broad money) in Mauritius in 2005 to that in 2010?
Provide a short and direct response. 0.95. What is the ratio of the Claims(annual growth as % of broad money) in Morocco in 2005 to that in 2010?
Provide a succinct answer. 0.91. What is the ratio of the Claims(annual growth as % of broad money) in Croatia in 2005 to that in 2011?
Ensure brevity in your answer.  3.77. What is the ratio of the Claims(annual growth as % of broad money) of Guatemala in 2005 to that in 2011?
Provide a succinct answer. 1.38. What is the ratio of the Claims(annual growth as % of broad money) of Mauritius in 2005 to that in 2011?
Provide a succinct answer. 0.87. What is the ratio of the Claims(annual growth as % of broad money) of Morocco in 2005 to that in 2011?
Give a very brief answer. 0.93. What is the ratio of the Claims(annual growth as % of broad money) of Croatia in 2006 to that in 2007?
Provide a short and direct response. 1.48. What is the ratio of the Claims(annual growth as % of broad money) of Guatemala in 2006 to that in 2007?
Provide a succinct answer. 1.35. What is the ratio of the Claims(annual growth as % of broad money) of Mauritius in 2006 to that in 2007?
Give a very brief answer. 0.81. What is the ratio of the Claims(annual growth as % of broad money) in Morocco in 2006 to that in 2007?
Offer a very short reply. 0.72. What is the ratio of the Claims(annual growth as % of broad money) in Croatia in 2006 to that in 2008?
Provide a succinct answer. 2.12. What is the ratio of the Claims(annual growth as % of broad money) in Guatemala in 2006 to that in 2008?
Offer a very short reply. 2.23. What is the ratio of the Claims(annual growth as % of broad money) in Mauritius in 2006 to that in 2008?
Your answer should be compact. 0.44. What is the ratio of the Claims(annual growth as % of broad money) of Morocco in 2006 to that in 2008?
Your answer should be compact. 0.78. What is the ratio of the Claims(annual growth as % of broad money) in Mauritius in 2006 to that in 2009?
Make the answer very short. 12.15. What is the ratio of the Claims(annual growth as % of broad money) of Morocco in 2006 to that in 2009?
Your response must be concise. 1.5. What is the ratio of the Claims(annual growth as % of broad money) in Croatia in 2006 to that in 2010?
Ensure brevity in your answer.  2.06. What is the ratio of the Claims(annual growth as % of broad money) in Guatemala in 2006 to that in 2010?
Ensure brevity in your answer.  6.88. What is the ratio of the Claims(annual growth as % of broad money) in Mauritius in 2006 to that in 2010?
Provide a short and direct response. 0.98. What is the ratio of the Claims(annual growth as % of broad money) of Morocco in 2006 to that in 2010?
Provide a succinct answer. 1.5. What is the ratio of the Claims(annual growth as % of broad money) in Croatia in 2006 to that in 2011?
Keep it short and to the point. 5.36. What is the ratio of the Claims(annual growth as % of broad money) in Guatemala in 2006 to that in 2011?
Give a very brief answer. 2.29. What is the ratio of the Claims(annual growth as % of broad money) of Mauritius in 2006 to that in 2011?
Offer a terse response. 0.91. What is the ratio of the Claims(annual growth as % of broad money) of Morocco in 2006 to that in 2011?
Make the answer very short. 1.53. What is the ratio of the Claims(annual growth as % of broad money) in Croatia in 2007 to that in 2008?
Provide a succinct answer. 1.43. What is the ratio of the Claims(annual growth as % of broad money) in Guatemala in 2007 to that in 2008?
Your answer should be compact. 1.65. What is the ratio of the Claims(annual growth as % of broad money) of Mauritius in 2007 to that in 2008?
Keep it short and to the point. 0.55. What is the ratio of the Claims(annual growth as % of broad money) of Morocco in 2007 to that in 2008?
Make the answer very short. 1.07. What is the ratio of the Claims(annual growth as % of broad money) of Mauritius in 2007 to that in 2009?
Keep it short and to the point. 14.99. What is the ratio of the Claims(annual growth as % of broad money) of Morocco in 2007 to that in 2009?
Your answer should be compact. 2.08. What is the ratio of the Claims(annual growth as % of broad money) in Croatia in 2007 to that in 2010?
Ensure brevity in your answer.  1.39. What is the ratio of the Claims(annual growth as % of broad money) of Guatemala in 2007 to that in 2010?
Ensure brevity in your answer.  5.08. What is the ratio of the Claims(annual growth as % of broad money) in Mauritius in 2007 to that in 2010?
Give a very brief answer. 1.21. What is the ratio of the Claims(annual growth as % of broad money) of Morocco in 2007 to that in 2010?
Offer a terse response. 2.07. What is the ratio of the Claims(annual growth as % of broad money) in Croatia in 2007 to that in 2011?
Make the answer very short. 3.62. What is the ratio of the Claims(annual growth as % of broad money) in Guatemala in 2007 to that in 2011?
Provide a succinct answer. 1.69. What is the ratio of the Claims(annual growth as % of broad money) in Mauritius in 2007 to that in 2011?
Ensure brevity in your answer.  1.12. What is the ratio of the Claims(annual growth as % of broad money) in Morocco in 2007 to that in 2011?
Your answer should be compact. 2.11. What is the ratio of the Claims(annual growth as % of broad money) of Mauritius in 2008 to that in 2009?
Your response must be concise. 27.45. What is the ratio of the Claims(annual growth as % of broad money) in Morocco in 2008 to that in 2009?
Your answer should be very brief. 1.94. What is the ratio of the Claims(annual growth as % of broad money) in Croatia in 2008 to that in 2010?
Your answer should be very brief. 0.97. What is the ratio of the Claims(annual growth as % of broad money) of Guatemala in 2008 to that in 2010?
Ensure brevity in your answer.  3.08. What is the ratio of the Claims(annual growth as % of broad money) of Mauritius in 2008 to that in 2010?
Keep it short and to the point. 2.22. What is the ratio of the Claims(annual growth as % of broad money) of Morocco in 2008 to that in 2010?
Provide a succinct answer. 1.93. What is the ratio of the Claims(annual growth as % of broad money) in Croatia in 2008 to that in 2011?
Your answer should be very brief. 2.53. What is the ratio of the Claims(annual growth as % of broad money) of Mauritius in 2008 to that in 2011?
Ensure brevity in your answer.  2.05. What is the ratio of the Claims(annual growth as % of broad money) in Morocco in 2008 to that in 2011?
Your response must be concise. 1.97. What is the ratio of the Claims(annual growth as % of broad money) in Mauritius in 2009 to that in 2010?
Ensure brevity in your answer.  0.08. What is the ratio of the Claims(annual growth as % of broad money) of Mauritius in 2009 to that in 2011?
Provide a succinct answer. 0.07. What is the ratio of the Claims(annual growth as % of broad money) in Morocco in 2009 to that in 2011?
Offer a terse response. 1.02. What is the ratio of the Claims(annual growth as % of broad money) in Croatia in 2010 to that in 2011?
Offer a very short reply. 2.6. What is the ratio of the Claims(annual growth as % of broad money) of Guatemala in 2010 to that in 2011?
Make the answer very short. 0.33. What is the ratio of the Claims(annual growth as % of broad money) of Mauritius in 2010 to that in 2011?
Give a very brief answer. 0.92. What is the ratio of the Claims(annual growth as % of broad money) in Morocco in 2010 to that in 2011?
Your response must be concise. 1.02. What is the difference between the highest and the second highest Claims(annual growth as % of broad money) of Croatia?
Provide a short and direct response. 6.55. What is the difference between the highest and the second highest Claims(annual growth as % of broad money) in Guatemala?
Keep it short and to the point. 4.66. What is the difference between the highest and the second highest Claims(annual growth as % of broad money) of Mauritius?
Your answer should be very brief. 9.95. What is the difference between the highest and the second highest Claims(annual growth as % of broad money) of Morocco?
Make the answer very short. 1.24. What is the difference between the highest and the lowest Claims(annual growth as % of broad money) of Croatia?
Make the answer very short. 22.09. What is the difference between the highest and the lowest Claims(annual growth as % of broad money) in Guatemala?
Give a very brief answer. 17.81. What is the difference between the highest and the lowest Claims(annual growth as % of broad money) of Mauritius?
Give a very brief answer. 21.12. What is the difference between the highest and the lowest Claims(annual growth as % of broad money) in Morocco?
Offer a very short reply. 10.44. 